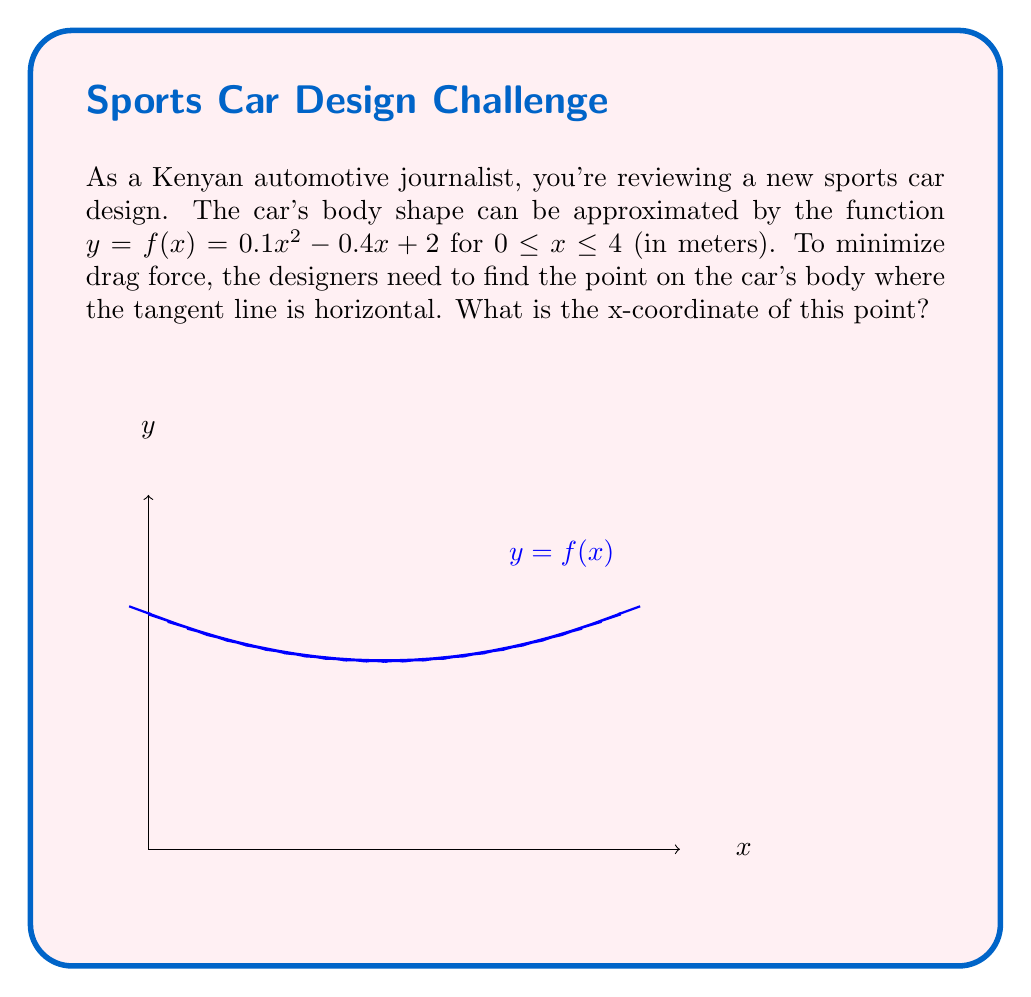Give your solution to this math problem. To find the point where the tangent line is horizontal, we need to find where the derivative of the function is zero. This is because a horizontal line has a slope of zero.

1) First, let's find the derivative of $f(x) = 0.1x^2 - 0.4x + 2$:
   
   $$f'(x) = 0.2x - 0.4$$

2) Now, we set this equal to zero and solve for x:
   
   $$0.2x - 0.4 = 0$$
   $$0.2x = 0.4$$
   $$x = 2$$

3) We can verify that this is within our domain of $0 \leq x \leq 4$.

4) To confirm this is a minimum point (which would minimize drag), we could check the second derivative:
   
   $$f''(x) = 0.2$$

   Since this is positive, we confirm that x = 2 gives us a minimum point.

Therefore, the x-coordinate where the tangent line is horizontal (and drag force is minimized) is 2 meters from the front of the car.
Answer: 2 meters 